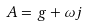<formula> <loc_0><loc_0><loc_500><loc_500>A = g + { \omega } j</formula> 